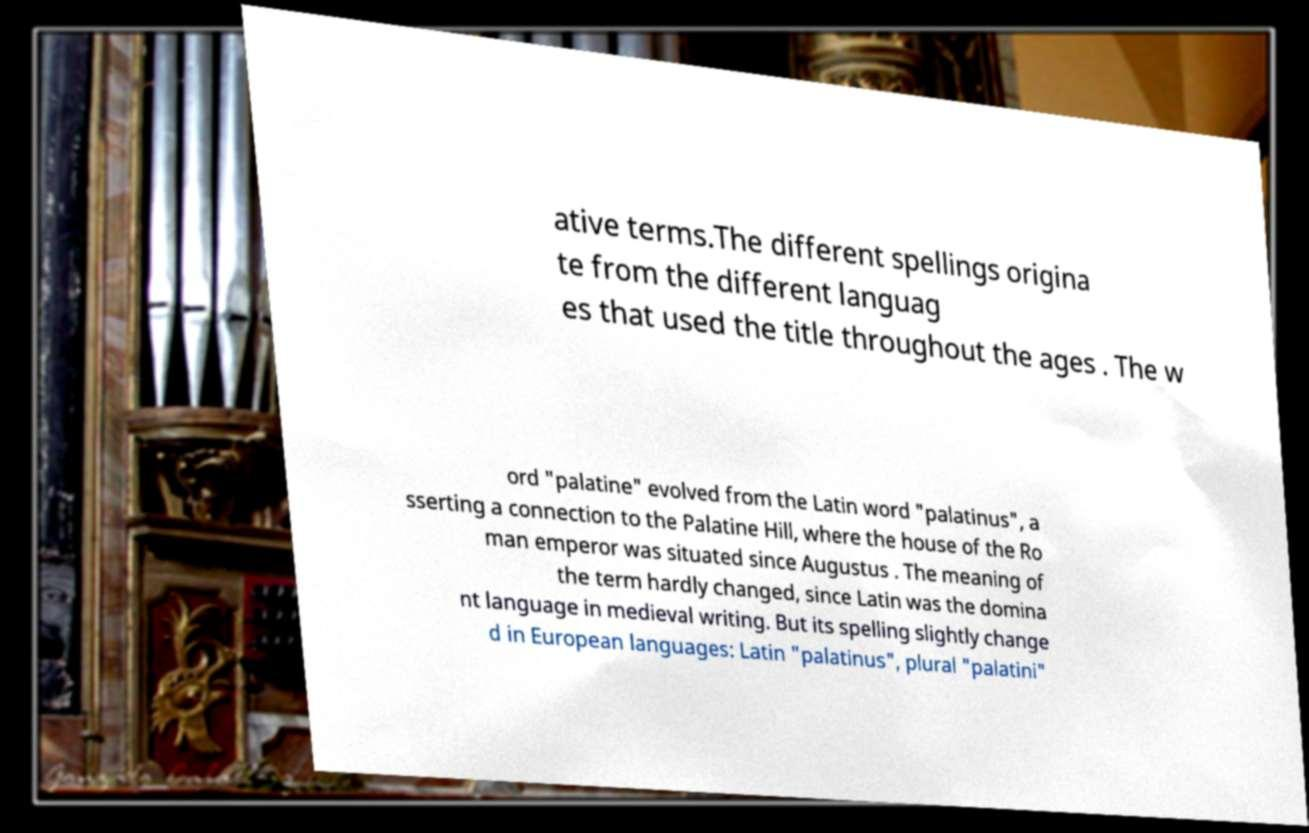Could you assist in decoding the text presented in this image and type it out clearly? ative terms.The different spellings origina te from the different languag es that used the title throughout the ages . The w ord "palatine" evolved from the Latin word "palatinus", a sserting a connection to the Palatine Hill, where the house of the Ro man emperor was situated since Augustus . The meaning of the term hardly changed, since Latin was the domina nt language in medieval writing. But its spelling slightly change d in European languages: Latin "palatinus", plural "palatini" 